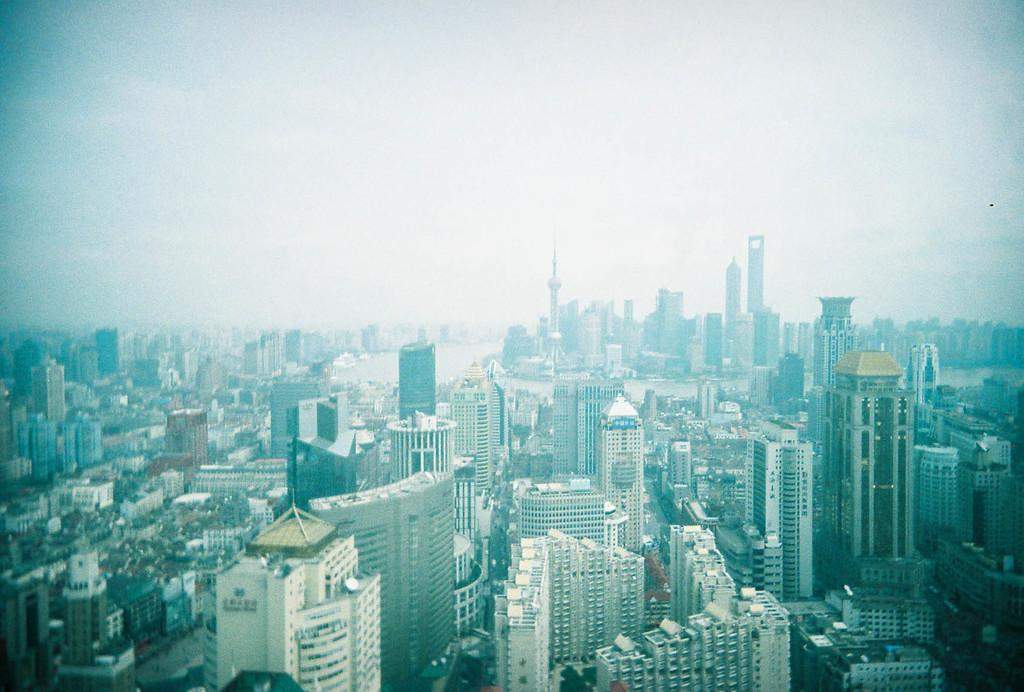What type of structures are present in the image? There is a group of buildings in the image. Are there any specific features of these buildings? Yes, there are towers in the image. What else can be seen in the image besides the buildings? There is a water body in the image. What is visible in the sky in the image? The sky is visible in the image, and it appears to be cloudy. Can you see any birds flying over the wing in the image? There is no wing or birds present in the image. 